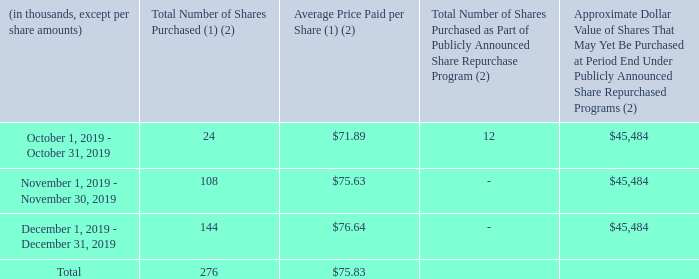Issuer purchases of equity securities
Common stock repurchased in the three months ended December 31, 2019:
(1) Shares withheld to cover the option exercise price and tax withholding obligations under the net settlement provisions of our stock compensation awards have been included in these amounts.
(2) See "Stock repurchase program" in Item 7 of this Annual Report for additional information.
What are the respective number of shares purchased in October and November 2019?
Answer scale should be: thousand. 24, 108. What are the respective number of shares purchased in November and December 2019?
Answer scale should be: thousand. 108, 144. What is the total number of shares purchased in the three months ended December 31, 2019?
Answer scale should be: thousand. 276. What is the average number of shares purchased in the three months ended December 31, 2019?
Answer scale should be: thousand. (24 + 108 + 144)/3 
Answer: 92. What percentage of the total shares purchased in the last three months of 2019 are bought in November?
Answer scale should be: percent. 108/276 
Answer: 39.13. What is the difference in the number of shares bought between October and November?
Answer scale should be: thousand. 108-24 
Answer: 84. 